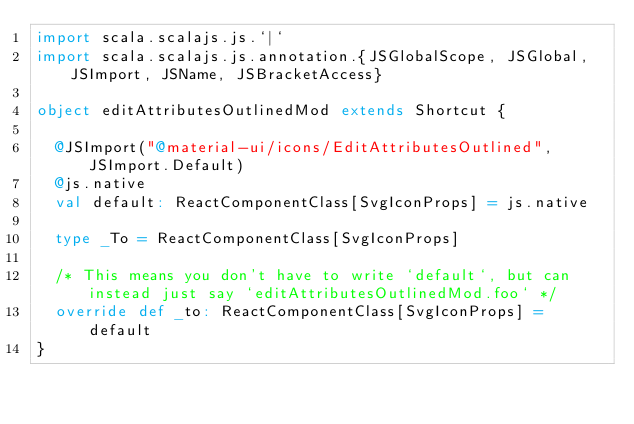Convert code to text. <code><loc_0><loc_0><loc_500><loc_500><_Scala_>import scala.scalajs.js.`|`
import scala.scalajs.js.annotation.{JSGlobalScope, JSGlobal, JSImport, JSName, JSBracketAccess}

object editAttributesOutlinedMod extends Shortcut {
  
  @JSImport("@material-ui/icons/EditAttributesOutlined", JSImport.Default)
  @js.native
  val default: ReactComponentClass[SvgIconProps] = js.native
  
  type _To = ReactComponentClass[SvgIconProps]
  
  /* This means you don't have to write `default`, but can instead just say `editAttributesOutlinedMod.foo` */
  override def _to: ReactComponentClass[SvgIconProps] = default
}
</code> 